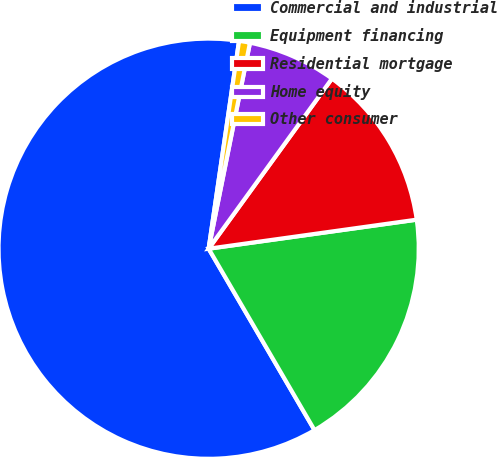Convert chart. <chart><loc_0><loc_0><loc_500><loc_500><pie_chart><fcel>Commercial and industrial<fcel>Equipment financing<fcel>Residential mortgage<fcel>Home equity<fcel>Other consumer<nl><fcel>60.72%<fcel>18.8%<fcel>12.81%<fcel>6.83%<fcel>0.84%<nl></chart> 